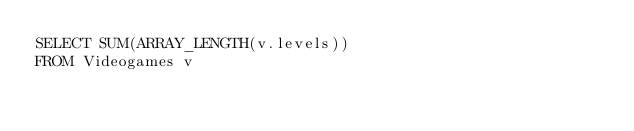Convert code to text. <code><loc_0><loc_0><loc_500><loc_500><_SQL_>SELECT SUM(ARRAY_LENGTH(v.levels))
FROM Videogames v
</code> 